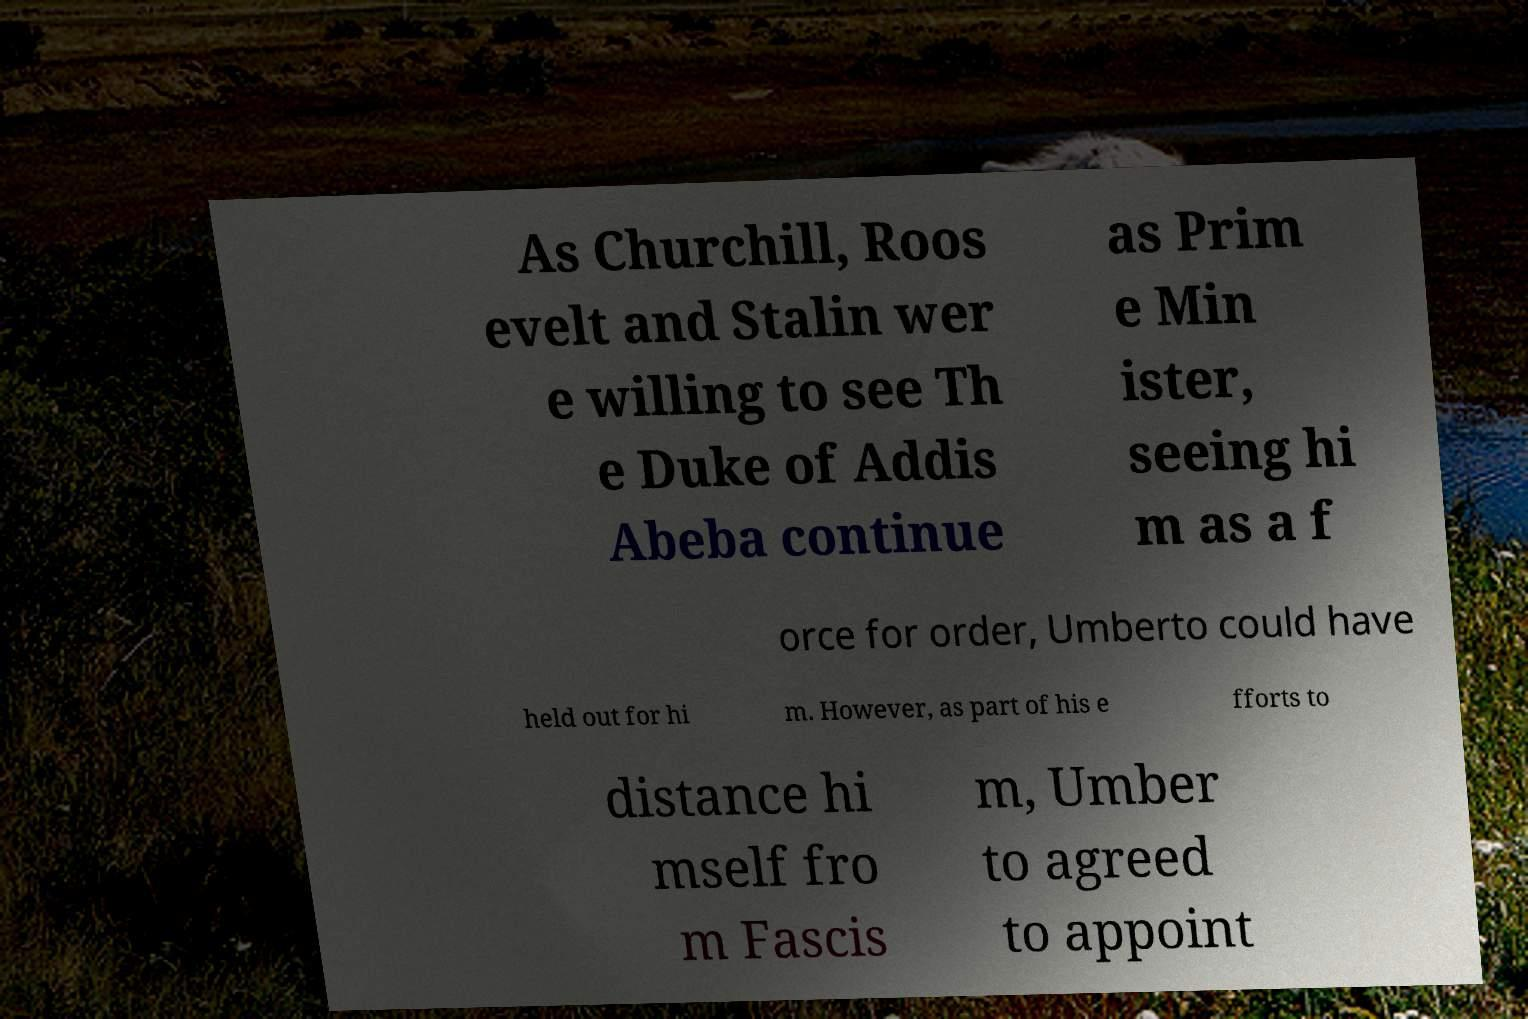Could you assist in decoding the text presented in this image and type it out clearly? As Churchill, Roos evelt and Stalin wer e willing to see Th e Duke of Addis Abeba continue as Prim e Min ister, seeing hi m as a f orce for order, Umberto could have held out for hi m. However, as part of his e fforts to distance hi mself fro m Fascis m, Umber to agreed to appoint 